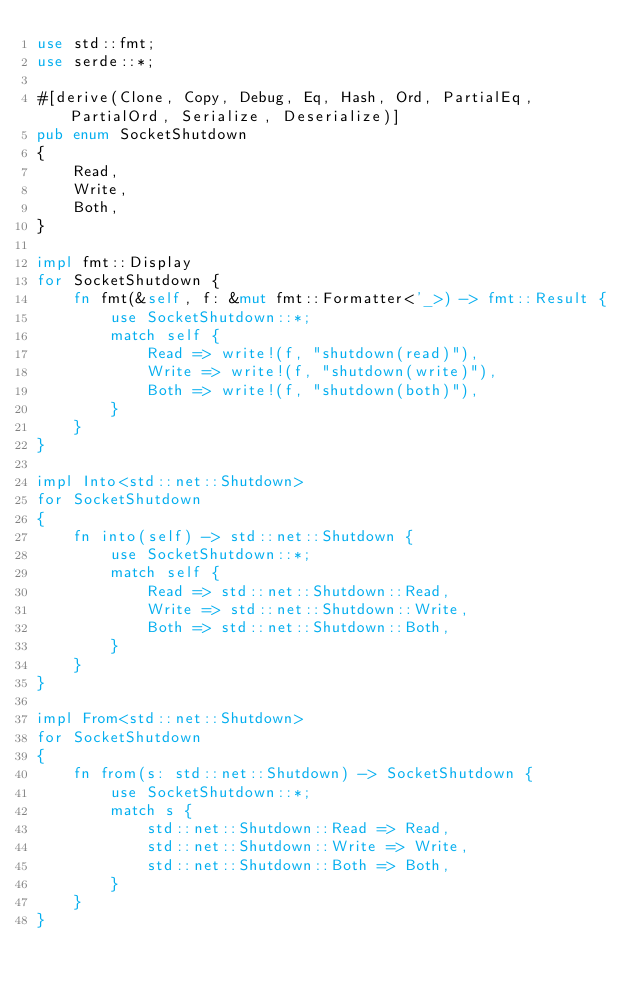Convert code to text. <code><loc_0><loc_0><loc_500><loc_500><_Rust_>use std::fmt;
use serde::*;

#[derive(Clone, Copy, Debug, Eq, Hash, Ord, PartialEq, PartialOrd, Serialize, Deserialize)]
pub enum SocketShutdown
{
    Read,
    Write,
    Both,
}

impl fmt::Display
for SocketShutdown {
    fn fmt(&self, f: &mut fmt::Formatter<'_>) -> fmt::Result {
        use SocketShutdown::*;
        match self {
            Read => write!(f, "shutdown(read)"),
            Write => write!(f, "shutdown(write)"),
            Both => write!(f, "shutdown(both)"),
        }
    }
}

impl Into<std::net::Shutdown>
for SocketShutdown
{
    fn into(self) -> std::net::Shutdown {
        use SocketShutdown::*;
        match self {
            Read => std::net::Shutdown::Read,
            Write => std::net::Shutdown::Write,
            Both => std::net::Shutdown::Both,
        }
    }
}

impl From<std::net::Shutdown>
for SocketShutdown
{
    fn from(s: std::net::Shutdown) -> SocketShutdown {
        use SocketShutdown::*;
        match s {
            std::net::Shutdown::Read => Read,
            std::net::Shutdown::Write => Write,
            std::net::Shutdown::Both => Both,
        }
    }
}
</code> 